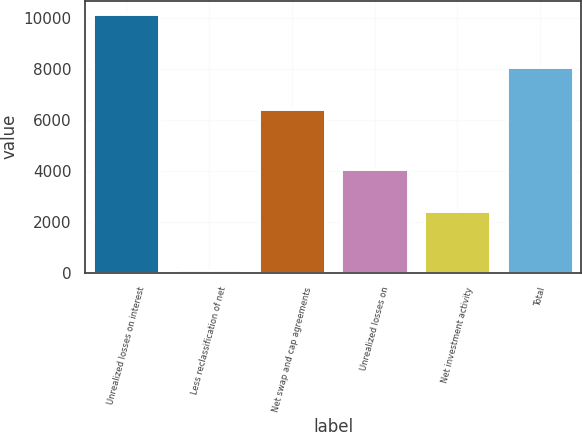Convert chart. <chart><loc_0><loc_0><loc_500><loc_500><bar_chart><fcel>Unrealized losses on interest<fcel>Less reclassification of net<fcel>Net swap and cap agreements<fcel>Unrealized losses on<fcel>Net investment activity<fcel>Total<nl><fcel>10154<fcel>123<fcel>6424<fcel>4046.5<fcel>2401<fcel>8069.5<nl></chart> 